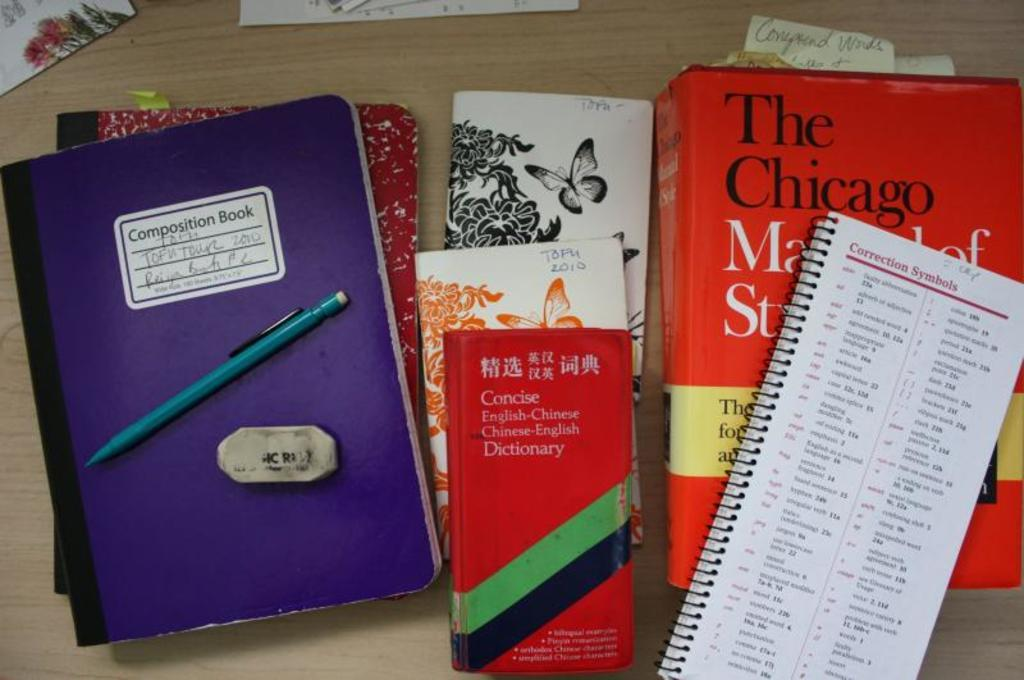<image>
Present a compact description of the photo's key features. A group of school books and composition books for somewhere in Chicago. 